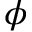Convert formula to latex. <formula><loc_0><loc_0><loc_500><loc_500>\phi</formula> 